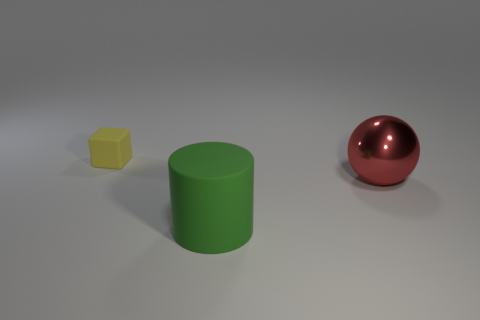How many objects are matte objects in front of the small thing or green matte cylinders?
Your answer should be very brief. 1. What is the size of the matte thing that is on the left side of the green matte thing?
Keep it short and to the point. Small. Are there fewer small objects than cyan metallic blocks?
Your answer should be very brief. No. Is the material of the large object in front of the ball the same as the thing that is to the right of the large rubber thing?
Ensure brevity in your answer.  No. There is a matte thing that is in front of the rubber thing that is left of the rubber thing that is on the right side of the yellow rubber object; what shape is it?
Your answer should be compact. Cylinder. How many tiny red cylinders are made of the same material as the large green cylinder?
Your answer should be very brief. 0. What number of green matte things are in front of the rubber thing to the right of the tiny matte object?
Your answer should be compact. 0. Does the rubber thing that is to the right of the yellow matte thing have the same color as the thing to the right of the green cylinder?
Your answer should be compact. No. What shape is the object that is to the left of the large metal thing and on the right side of the tiny object?
Keep it short and to the point. Cylinder. Are there any small yellow things that have the same shape as the large red object?
Keep it short and to the point. No. 